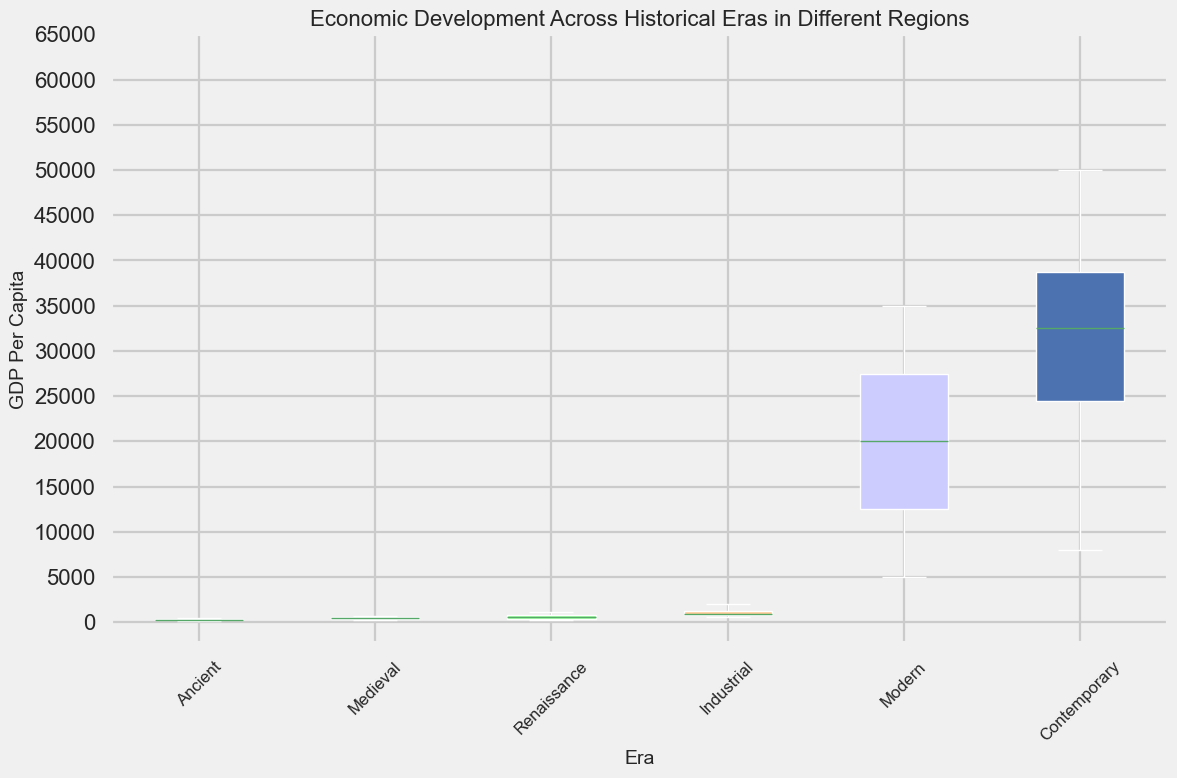What is the average GDP per capita during the Ancient era? To find the average GDP per capita during the Ancient era, sum the GDP per capita values: 450 (Europe) + 300 (Asia) + 250 (Africa) + 150 (Americas) = 1150. Then, divide by the number of regions (4): 1150 / 4 = 287.5
Answer: 287.5 Which era shows the greatest range in GDP per capita? The range is calculated as the difference between the maximum and minimum values for each era. For the Contemporary era, the range is 50000 (Europe) - 8000 (Africa) = 42000. Comparing this to other eras, it is the greatest.
Answer: Contemporary Which region consistently shows the highest GDP per capita across all eras? By examining the figure, we see the highest GDP per capita across all eras is always in Europe.
Answer: Europe What is the difference in median GDP per capita between the Renaissance and Industrial eras? Find the median of GDP per capita for each era. Renaissance: (300 + 400 + 700 + 1100)/4 = 625; Industrial: (600 + 800 + 1000 + 2000)/4 = 1100. The difference is 1100 - 625 = 475.
Answer: 475 Which era shows the smallest interquartile range of GDP per capita? The interquartile range (IQR) is the difference between the 75th and 25th percentiles. Visual inspection suggests the Renaissance era, where the IQR appears smallest.
Answer: Renaissance Compare the median GDP per capita between the Medieval era and the Modern era. Which is higher and by how much? Median GDP per capita for Medieval: (200+350+500+650)/4 = 425; for Modern: (5000+15000+25000+35000)/4 = 20000. Modern era has a higher median by 20000 - 425 = 19575.
Answer: Modern by 19575 How does the GDP per capita of Africa in the Medieval era compare to that in the Industrial era? GDP per capita for Africa: Medieval (350) vs Industrial (600). Industrial era has a higher GDP per capita.
Answer: Industrial is higher What are the GDP per capita values for the Americas during the Renaissance and Contemporary eras? From the plot, the GDP per capita values for the Americas are 300 during the Renaissance and 35000 during the Contemporary era.
Answer: Renaissance: 300, Contemporary: 35000 Which era shows the least economic development in the Americas based on GDP per capita? By comparing the GDP per capita for the Americas across all eras, the Ancient era has the lowest value of 150.
Answer: Ancient 